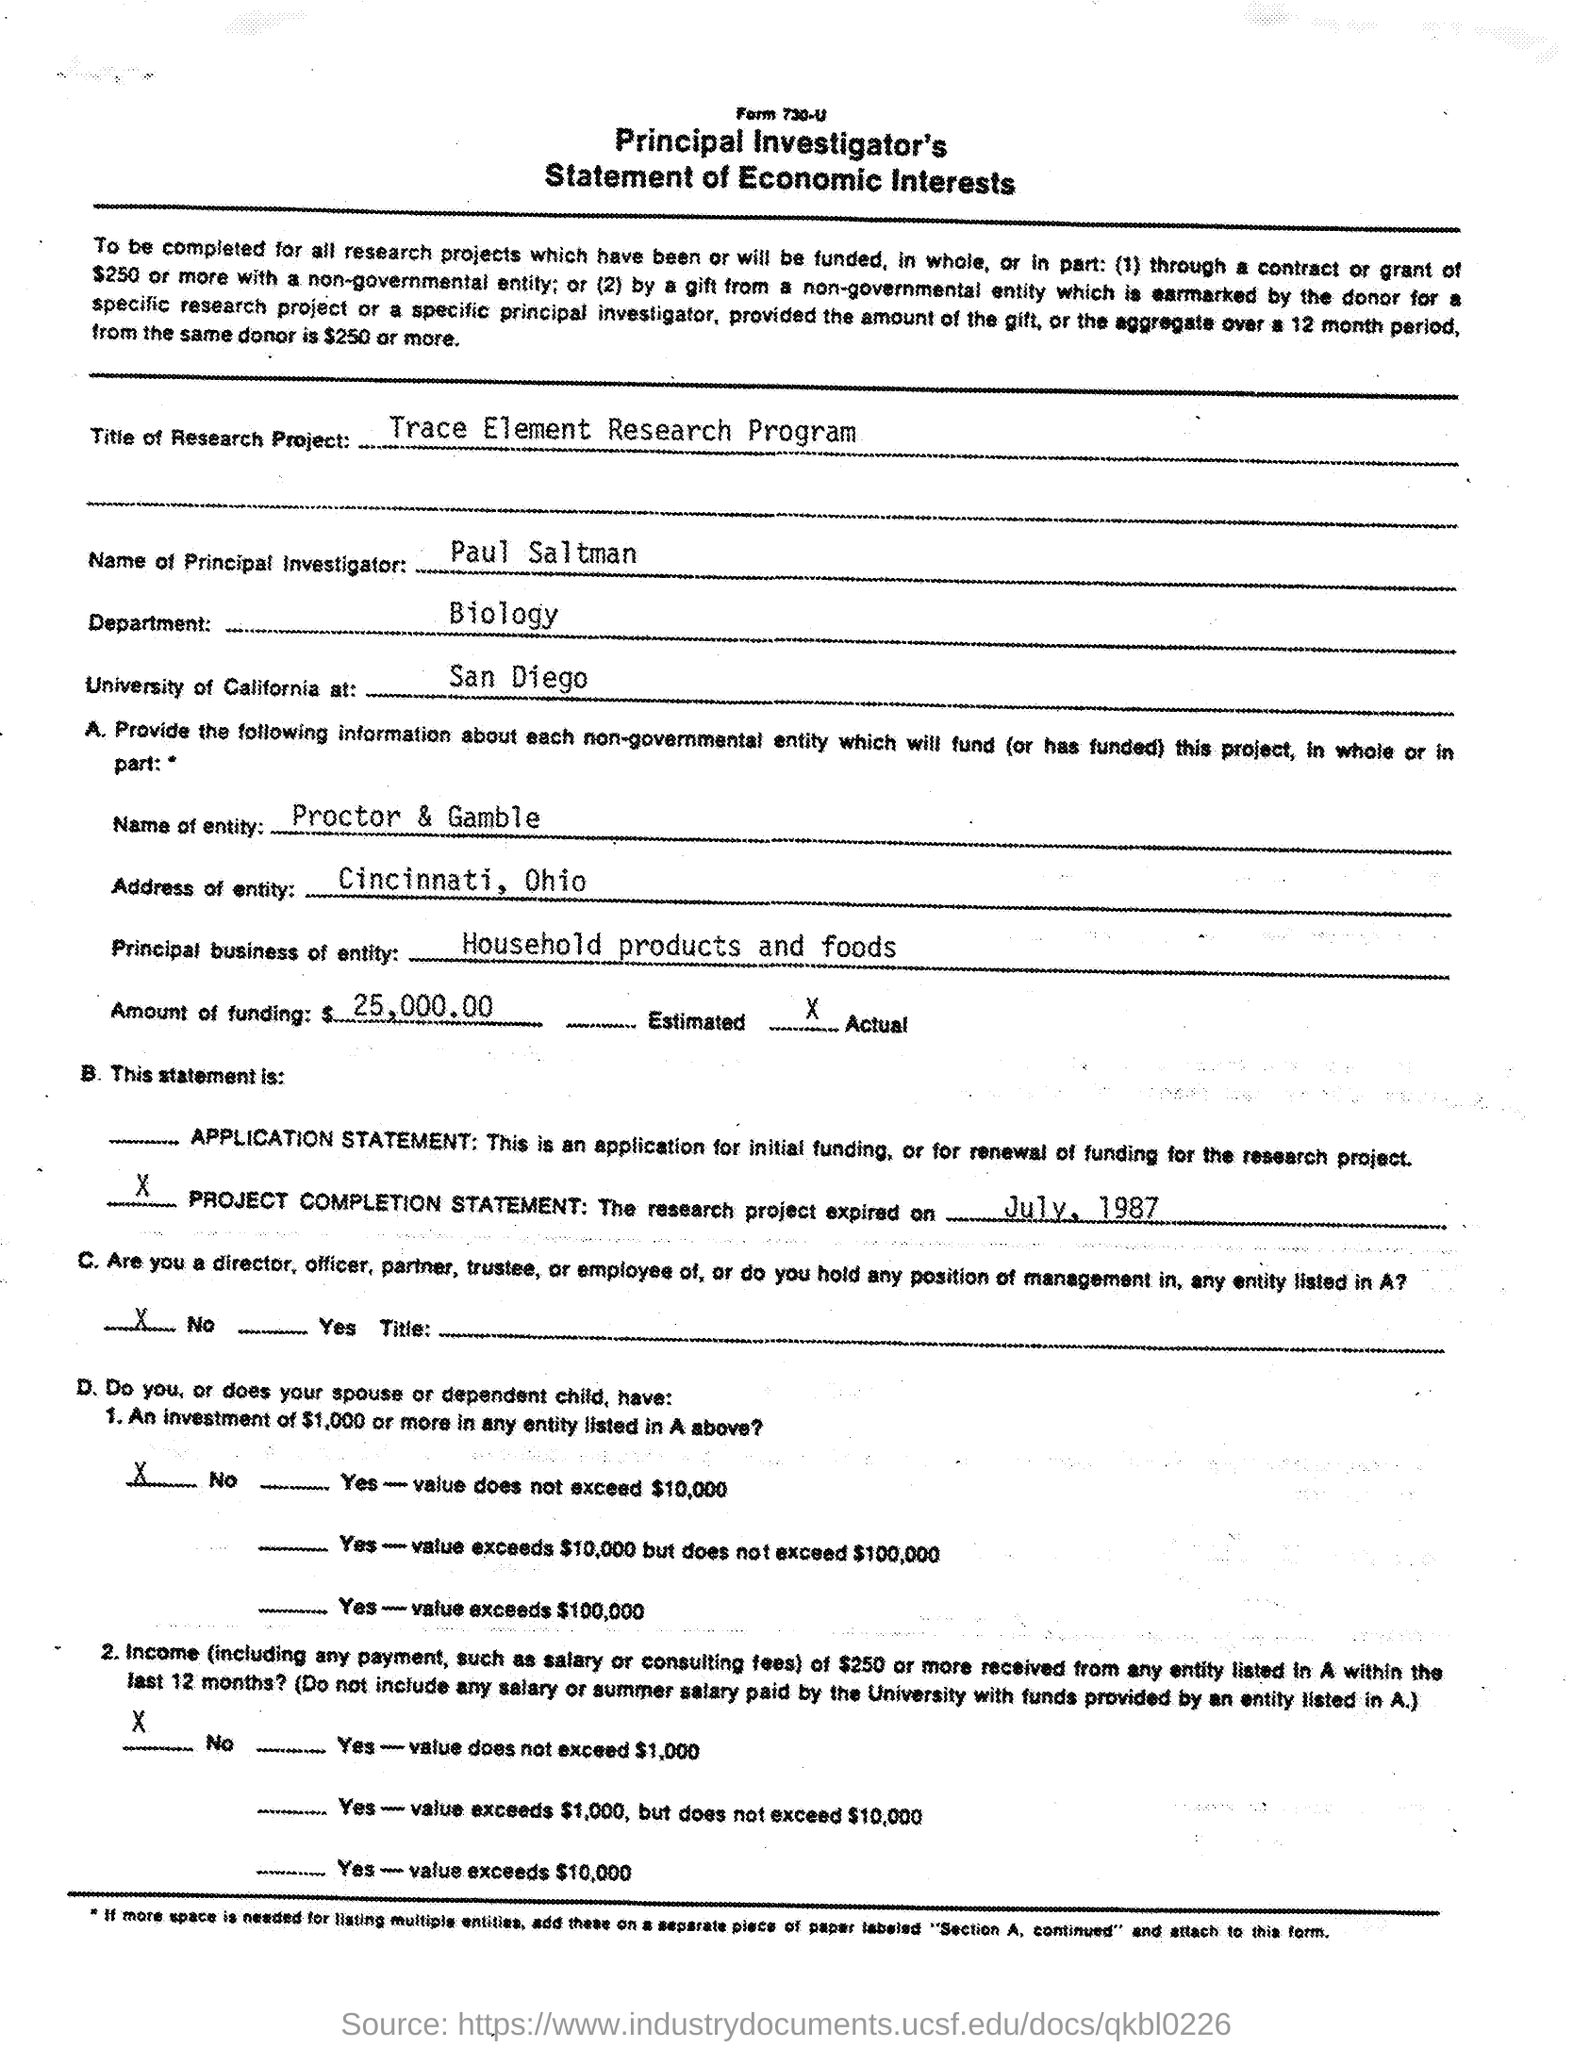Specify some key components in this picture. The Biology department is named in the given form. The given form mentions an entity named Proctor & Gamble. The principal investigator's name is Paul Saltman. The entity mentioned in the given form is located in Cincinnati, Ohio. The title of the research project is the Trace Element Research Program. 